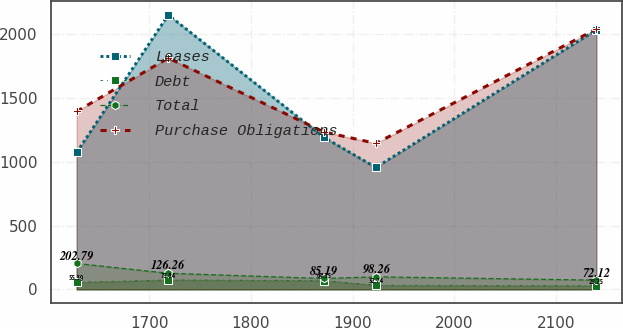Convert chart. <chart><loc_0><loc_0><loc_500><loc_500><line_chart><ecel><fcel>Leases<fcel>Debt<fcel>Total<fcel>Purchase Obligations<nl><fcel>1628.8<fcel>1074.46<fcel>55.39<fcel>202.79<fcel>1396.17<nl><fcel>1718.84<fcel>2153.34<fcel>73.84<fcel>126.26<fcel>1814.89<nl><fcel>1871.79<fcel>1192.79<fcel>69.35<fcel>85.19<fcel>1235.04<nl><fcel>1922.87<fcel>956.13<fcel>32.74<fcel>98.26<fcel>1145.38<nl><fcel>2139.55<fcel>2035.01<fcel>28.25<fcel>72.12<fcel>2042<nl></chart> 